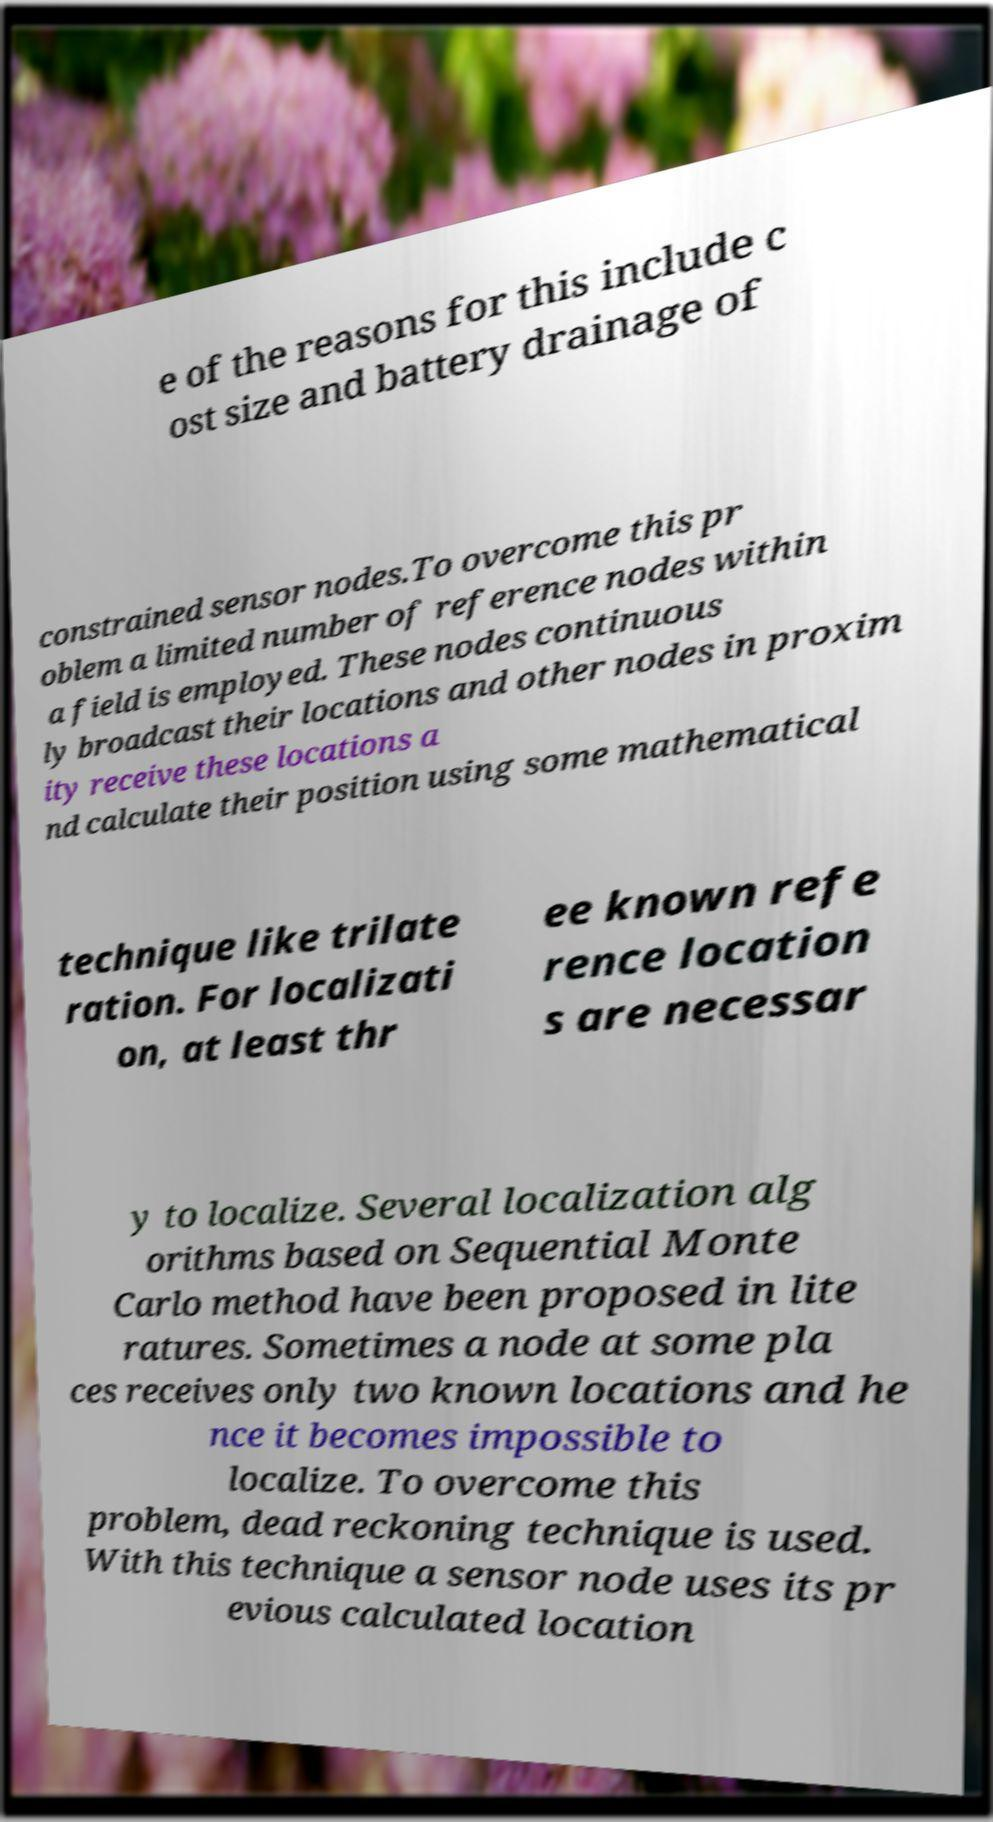Can you accurately transcribe the text from the provided image for me? e of the reasons for this include c ost size and battery drainage of constrained sensor nodes.To overcome this pr oblem a limited number of reference nodes within a field is employed. These nodes continuous ly broadcast their locations and other nodes in proxim ity receive these locations a nd calculate their position using some mathematical technique like trilate ration. For localizati on, at least thr ee known refe rence location s are necessar y to localize. Several localization alg orithms based on Sequential Monte Carlo method have been proposed in lite ratures. Sometimes a node at some pla ces receives only two known locations and he nce it becomes impossible to localize. To overcome this problem, dead reckoning technique is used. With this technique a sensor node uses its pr evious calculated location 